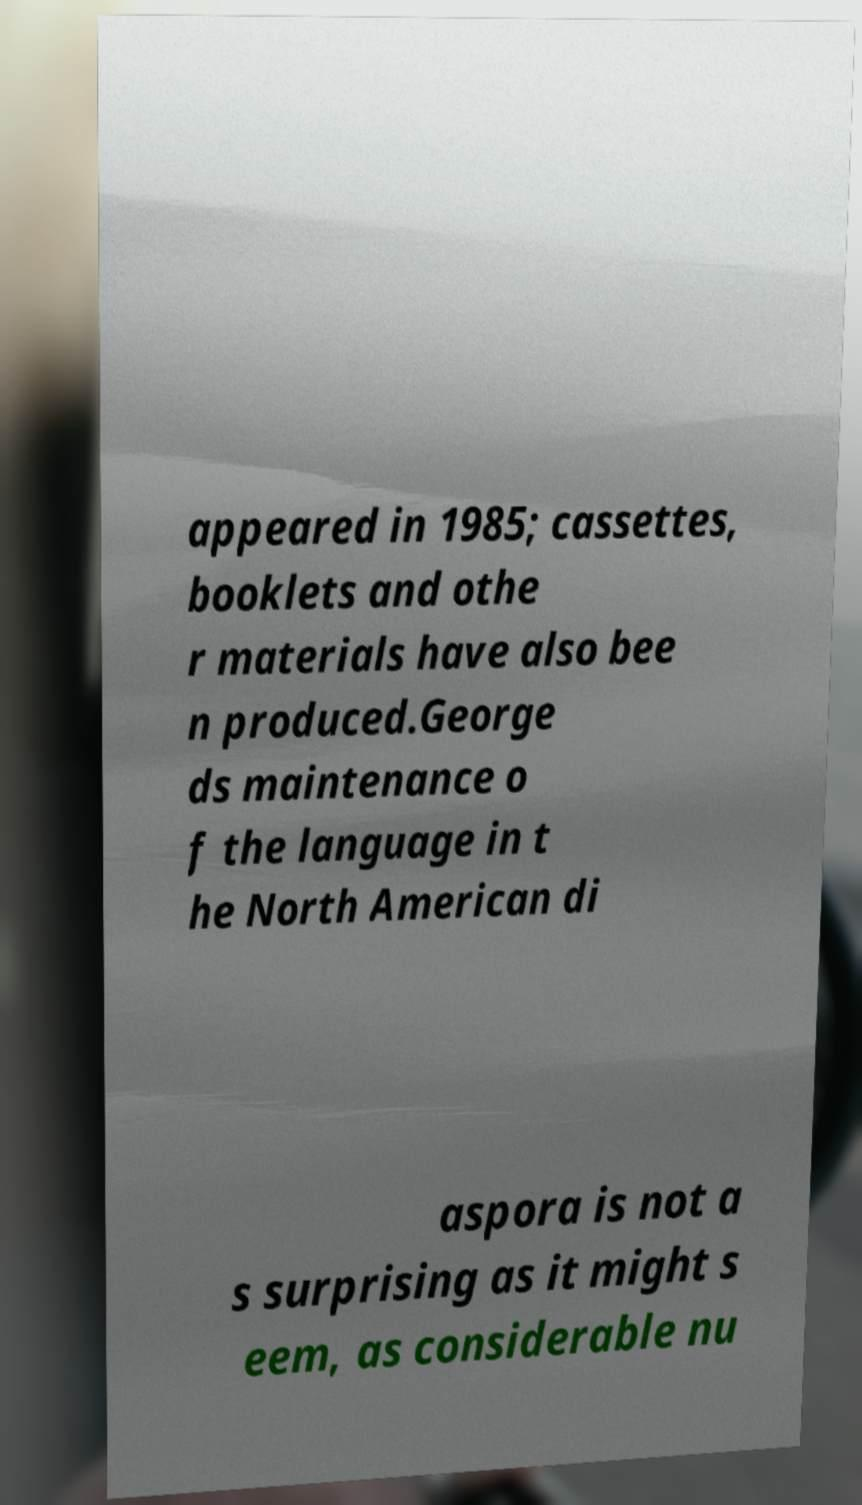For documentation purposes, I need the text within this image transcribed. Could you provide that? appeared in 1985; cassettes, booklets and othe r materials have also bee n produced.George ds maintenance o f the language in t he North American di aspora is not a s surprising as it might s eem, as considerable nu 